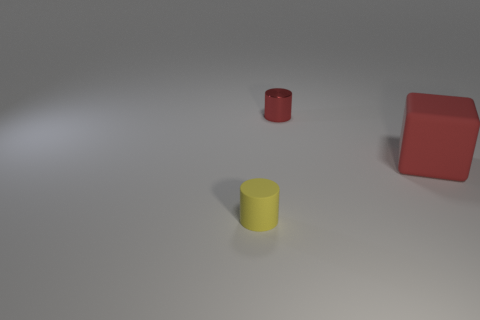Add 1 small yellow cylinders. How many objects exist? 4 Subtract all cylinders. How many objects are left? 1 Subtract 1 cylinders. How many cylinders are left? 1 Subtract 0 purple cubes. How many objects are left? 3 Subtract all green blocks. Subtract all gray balls. How many blocks are left? 1 Subtract all big yellow matte objects. Subtract all big red objects. How many objects are left? 2 Add 1 large red objects. How many large red objects are left? 2 Add 2 large red objects. How many large red objects exist? 3 